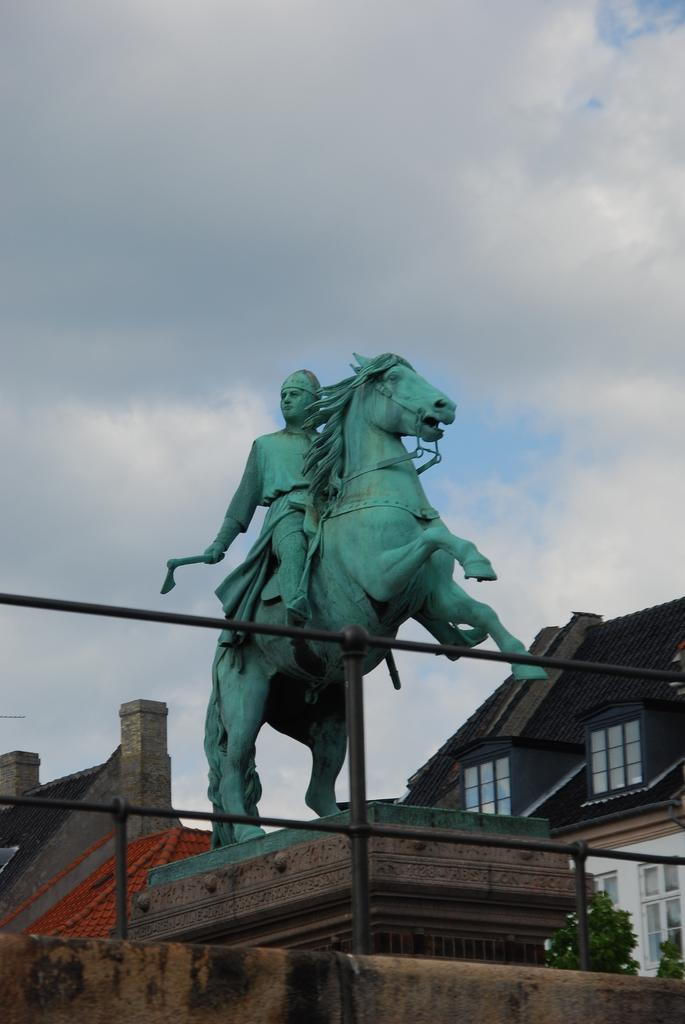What is the main subject in the center of the image? There is a statue in the center of the image. What type of structures can be seen in the image? There are houses with roofs and windows in the image. What type of vegetation is visible in the image? Trees are visible in the image. What type of barrier is present in the image? There is a fence in the image. What is the condition of the sky in the image? The sky is visible and appears cloudy. What type of furniture is depicted in the image? There is no furniture present in the image. What is your opinion on the statue's artistic value in the image? The question asks for an opinion, which is not based on the facts provided about the image. 